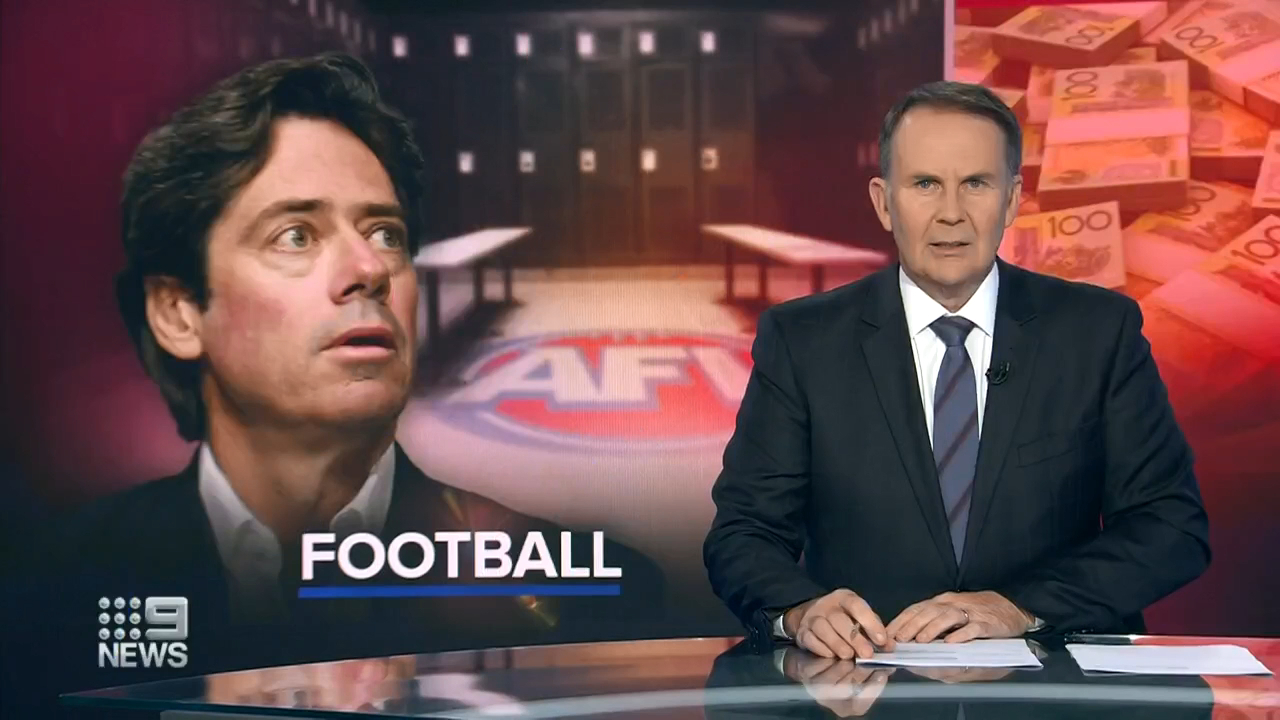Picture a world where the news anchor is delivering a positive update about the sport. How would his expression and the background graphic change? In a world where the news anchor is delivering a positive update about Australian Football, his expression would likely shift to one of enthusiasm and optimism. He might be smiling or exuding a more relaxed demeanor. The background graphic would also reflect this positive tone, perhaps showing images of triumphant players celebrating victories, fans in the stands cheering, and vibrant visuals highlighting the successes and advancements within the sport. Bright colors and dynamic scenes would dominate, conveying a sense of excitement and celebration. Describe a potential story of triumph that he could be reporting on. The news anchor could be reporting on a heartwarming story of an underdog team rising to prominence against all odds. This team, initially riddled with financial issues and considered unlikely to succeed, received an outpouring of community support. With the help of dedicated fans, local sponsors, and passionate volunteers, they managed to secure essential funding and resources. Their journey to the top was marked by relentless hard work, exceptional teamwork, and a series of stunning victories. Their success story not only brought joy to their home city but also inspired other struggling teams, symbolizing the power of perseverance and community spirit in triumphing over adversity. 